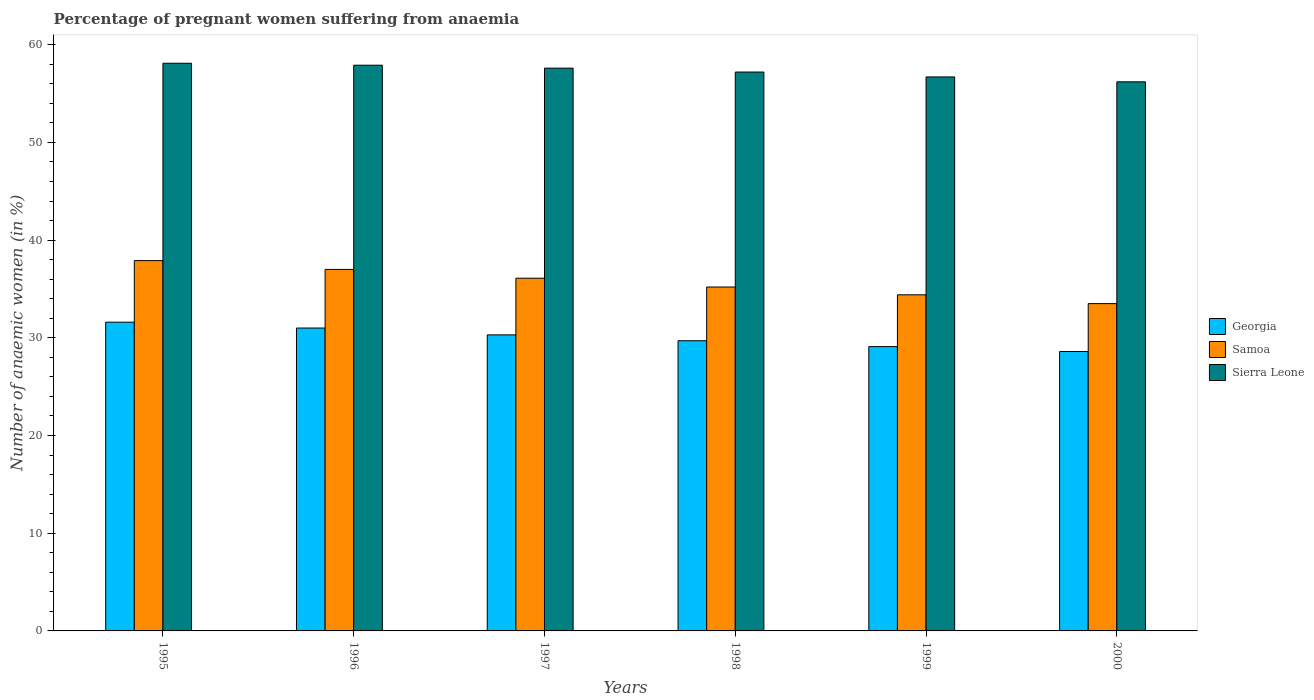How many different coloured bars are there?
Your response must be concise. 3. How many groups of bars are there?
Make the answer very short. 6. How many bars are there on the 2nd tick from the right?
Ensure brevity in your answer.  3. What is the number of anaemic women in Georgia in 1997?
Keep it short and to the point. 30.3. Across all years, what is the maximum number of anaemic women in Samoa?
Your response must be concise. 37.9. Across all years, what is the minimum number of anaemic women in Sierra Leone?
Your answer should be compact. 56.2. What is the total number of anaemic women in Sierra Leone in the graph?
Keep it short and to the point. 343.7. What is the difference between the number of anaemic women in Samoa in 1996 and that in 1999?
Ensure brevity in your answer.  2.6. What is the difference between the number of anaemic women in Sierra Leone in 2000 and the number of anaemic women in Georgia in 1997?
Your answer should be very brief. 25.9. What is the average number of anaemic women in Samoa per year?
Your answer should be compact. 35.68. In the year 1999, what is the difference between the number of anaemic women in Georgia and number of anaemic women in Samoa?
Your answer should be very brief. -5.3. In how many years, is the number of anaemic women in Georgia greater than 56 %?
Offer a terse response. 0. What is the ratio of the number of anaemic women in Samoa in 1995 to that in 1996?
Your answer should be very brief. 1.02. Is the number of anaemic women in Samoa in 1999 less than that in 2000?
Provide a succinct answer. No. What is the difference between the highest and the second highest number of anaemic women in Samoa?
Provide a short and direct response. 0.9. What is the difference between the highest and the lowest number of anaemic women in Samoa?
Offer a terse response. 4.4. In how many years, is the number of anaemic women in Samoa greater than the average number of anaemic women in Samoa taken over all years?
Provide a short and direct response. 3. What does the 2nd bar from the left in 1997 represents?
Ensure brevity in your answer.  Samoa. What does the 2nd bar from the right in 1999 represents?
Your response must be concise. Samoa. How many bars are there?
Your answer should be compact. 18. Are all the bars in the graph horizontal?
Make the answer very short. No. What is the difference between two consecutive major ticks on the Y-axis?
Keep it short and to the point. 10. Does the graph contain grids?
Your answer should be very brief. No. How many legend labels are there?
Ensure brevity in your answer.  3. How are the legend labels stacked?
Your answer should be very brief. Vertical. What is the title of the graph?
Your response must be concise. Percentage of pregnant women suffering from anaemia. What is the label or title of the Y-axis?
Your answer should be very brief. Number of anaemic women (in %). What is the Number of anaemic women (in %) in Georgia in 1995?
Your answer should be compact. 31.6. What is the Number of anaemic women (in %) in Samoa in 1995?
Your response must be concise. 37.9. What is the Number of anaemic women (in %) in Sierra Leone in 1995?
Keep it short and to the point. 58.1. What is the Number of anaemic women (in %) of Samoa in 1996?
Your answer should be very brief. 37. What is the Number of anaemic women (in %) in Sierra Leone in 1996?
Provide a short and direct response. 57.9. What is the Number of anaemic women (in %) of Georgia in 1997?
Ensure brevity in your answer.  30.3. What is the Number of anaemic women (in %) of Samoa in 1997?
Your answer should be very brief. 36.1. What is the Number of anaemic women (in %) in Sierra Leone in 1997?
Keep it short and to the point. 57.6. What is the Number of anaemic women (in %) of Georgia in 1998?
Offer a very short reply. 29.7. What is the Number of anaemic women (in %) in Samoa in 1998?
Ensure brevity in your answer.  35.2. What is the Number of anaemic women (in %) of Sierra Leone in 1998?
Give a very brief answer. 57.2. What is the Number of anaemic women (in %) in Georgia in 1999?
Ensure brevity in your answer.  29.1. What is the Number of anaemic women (in %) in Samoa in 1999?
Offer a terse response. 34.4. What is the Number of anaemic women (in %) of Sierra Leone in 1999?
Provide a succinct answer. 56.7. What is the Number of anaemic women (in %) in Georgia in 2000?
Give a very brief answer. 28.6. What is the Number of anaemic women (in %) of Samoa in 2000?
Your answer should be compact. 33.5. What is the Number of anaemic women (in %) of Sierra Leone in 2000?
Provide a short and direct response. 56.2. Across all years, what is the maximum Number of anaemic women (in %) of Georgia?
Keep it short and to the point. 31.6. Across all years, what is the maximum Number of anaemic women (in %) of Samoa?
Your response must be concise. 37.9. Across all years, what is the maximum Number of anaemic women (in %) of Sierra Leone?
Provide a short and direct response. 58.1. Across all years, what is the minimum Number of anaemic women (in %) in Georgia?
Provide a succinct answer. 28.6. Across all years, what is the minimum Number of anaemic women (in %) in Samoa?
Keep it short and to the point. 33.5. Across all years, what is the minimum Number of anaemic women (in %) of Sierra Leone?
Your answer should be very brief. 56.2. What is the total Number of anaemic women (in %) of Georgia in the graph?
Offer a terse response. 180.3. What is the total Number of anaemic women (in %) of Samoa in the graph?
Make the answer very short. 214.1. What is the total Number of anaemic women (in %) in Sierra Leone in the graph?
Your answer should be compact. 343.7. What is the difference between the Number of anaemic women (in %) in Samoa in 1995 and that in 1996?
Provide a succinct answer. 0.9. What is the difference between the Number of anaemic women (in %) of Samoa in 1995 and that in 1997?
Your response must be concise. 1.8. What is the difference between the Number of anaemic women (in %) of Georgia in 1995 and that in 1998?
Ensure brevity in your answer.  1.9. What is the difference between the Number of anaemic women (in %) in Samoa in 1995 and that in 1998?
Ensure brevity in your answer.  2.7. What is the difference between the Number of anaemic women (in %) of Samoa in 1995 and that in 1999?
Your answer should be very brief. 3.5. What is the difference between the Number of anaemic women (in %) in Sierra Leone in 1995 and that in 1999?
Offer a very short reply. 1.4. What is the difference between the Number of anaemic women (in %) of Georgia in 1995 and that in 2000?
Your answer should be very brief. 3. What is the difference between the Number of anaemic women (in %) in Samoa in 1995 and that in 2000?
Offer a terse response. 4.4. What is the difference between the Number of anaemic women (in %) of Sierra Leone in 1995 and that in 2000?
Make the answer very short. 1.9. What is the difference between the Number of anaemic women (in %) of Samoa in 1996 and that in 1997?
Offer a terse response. 0.9. What is the difference between the Number of anaemic women (in %) in Sierra Leone in 1996 and that in 1997?
Provide a succinct answer. 0.3. What is the difference between the Number of anaemic women (in %) of Georgia in 1996 and that in 1998?
Keep it short and to the point. 1.3. What is the difference between the Number of anaemic women (in %) in Sierra Leone in 1996 and that in 1998?
Your response must be concise. 0.7. What is the difference between the Number of anaemic women (in %) of Samoa in 1996 and that in 1999?
Provide a succinct answer. 2.6. What is the difference between the Number of anaemic women (in %) in Sierra Leone in 1996 and that in 1999?
Make the answer very short. 1.2. What is the difference between the Number of anaemic women (in %) in Samoa in 1996 and that in 2000?
Provide a succinct answer. 3.5. What is the difference between the Number of anaemic women (in %) in Sierra Leone in 1996 and that in 2000?
Your answer should be compact. 1.7. What is the difference between the Number of anaemic women (in %) in Georgia in 1997 and that in 1998?
Provide a short and direct response. 0.6. What is the difference between the Number of anaemic women (in %) of Samoa in 1997 and that in 1998?
Provide a succinct answer. 0.9. What is the difference between the Number of anaemic women (in %) in Samoa in 1997 and that in 1999?
Your response must be concise. 1.7. What is the difference between the Number of anaemic women (in %) in Sierra Leone in 1997 and that in 1999?
Provide a short and direct response. 0.9. What is the difference between the Number of anaemic women (in %) in Sierra Leone in 1997 and that in 2000?
Your response must be concise. 1.4. What is the difference between the Number of anaemic women (in %) in Georgia in 1998 and that in 1999?
Your answer should be very brief. 0.6. What is the difference between the Number of anaemic women (in %) of Sierra Leone in 1998 and that in 1999?
Your response must be concise. 0.5. What is the difference between the Number of anaemic women (in %) in Samoa in 1998 and that in 2000?
Ensure brevity in your answer.  1.7. What is the difference between the Number of anaemic women (in %) of Sierra Leone in 1998 and that in 2000?
Provide a succinct answer. 1. What is the difference between the Number of anaemic women (in %) in Samoa in 1999 and that in 2000?
Your answer should be very brief. 0.9. What is the difference between the Number of anaemic women (in %) in Georgia in 1995 and the Number of anaemic women (in %) in Sierra Leone in 1996?
Keep it short and to the point. -26.3. What is the difference between the Number of anaemic women (in %) of Georgia in 1995 and the Number of anaemic women (in %) of Samoa in 1997?
Give a very brief answer. -4.5. What is the difference between the Number of anaemic women (in %) of Samoa in 1995 and the Number of anaemic women (in %) of Sierra Leone in 1997?
Your answer should be compact. -19.7. What is the difference between the Number of anaemic women (in %) of Georgia in 1995 and the Number of anaemic women (in %) of Sierra Leone in 1998?
Offer a terse response. -25.6. What is the difference between the Number of anaemic women (in %) in Samoa in 1995 and the Number of anaemic women (in %) in Sierra Leone in 1998?
Ensure brevity in your answer.  -19.3. What is the difference between the Number of anaemic women (in %) in Georgia in 1995 and the Number of anaemic women (in %) in Samoa in 1999?
Your answer should be compact. -2.8. What is the difference between the Number of anaemic women (in %) of Georgia in 1995 and the Number of anaemic women (in %) of Sierra Leone in 1999?
Provide a short and direct response. -25.1. What is the difference between the Number of anaemic women (in %) of Samoa in 1995 and the Number of anaemic women (in %) of Sierra Leone in 1999?
Give a very brief answer. -18.8. What is the difference between the Number of anaemic women (in %) in Georgia in 1995 and the Number of anaemic women (in %) in Sierra Leone in 2000?
Keep it short and to the point. -24.6. What is the difference between the Number of anaemic women (in %) in Samoa in 1995 and the Number of anaemic women (in %) in Sierra Leone in 2000?
Your response must be concise. -18.3. What is the difference between the Number of anaemic women (in %) of Georgia in 1996 and the Number of anaemic women (in %) of Samoa in 1997?
Your response must be concise. -5.1. What is the difference between the Number of anaemic women (in %) of Georgia in 1996 and the Number of anaemic women (in %) of Sierra Leone in 1997?
Provide a short and direct response. -26.6. What is the difference between the Number of anaemic women (in %) in Samoa in 1996 and the Number of anaemic women (in %) in Sierra Leone in 1997?
Your response must be concise. -20.6. What is the difference between the Number of anaemic women (in %) of Georgia in 1996 and the Number of anaemic women (in %) of Samoa in 1998?
Ensure brevity in your answer.  -4.2. What is the difference between the Number of anaemic women (in %) of Georgia in 1996 and the Number of anaemic women (in %) of Sierra Leone in 1998?
Provide a short and direct response. -26.2. What is the difference between the Number of anaemic women (in %) in Samoa in 1996 and the Number of anaemic women (in %) in Sierra Leone in 1998?
Ensure brevity in your answer.  -20.2. What is the difference between the Number of anaemic women (in %) in Georgia in 1996 and the Number of anaemic women (in %) in Samoa in 1999?
Give a very brief answer. -3.4. What is the difference between the Number of anaemic women (in %) of Georgia in 1996 and the Number of anaemic women (in %) of Sierra Leone in 1999?
Keep it short and to the point. -25.7. What is the difference between the Number of anaemic women (in %) of Samoa in 1996 and the Number of anaemic women (in %) of Sierra Leone in 1999?
Provide a succinct answer. -19.7. What is the difference between the Number of anaemic women (in %) in Georgia in 1996 and the Number of anaemic women (in %) in Samoa in 2000?
Ensure brevity in your answer.  -2.5. What is the difference between the Number of anaemic women (in %) of Georgia in 1996 and the Number of anaemic women (in %) of Sierra Leone in 2000?
Ensure brevity in your answer.  -25.2. What is the difference between the Number of anaemic women (in %) of Samoa in 1996 and the Number of anaemic women (in %) of Sierra Leone in 2000?
Offer a very short reply. -19.2. What is the difference between the Number of anaemic women (in %) of Georgia in 1997 and the Number of anaemic women (in %) of Sierra Leone in 1998?
Ensure brevity in your answer.  -26.9. What is the difference between the Number of anaemic women (in %) of Samoa in 1997 and the Number of anaemic women (in %) of Sierra Leone in 1998?
Your answer should be very brief. -21.1. What is the difference between the Number of anaemic women (in %) in Georgia in 1997 and the Number of anaemic women (in %) in Sierra Leone in 1999?
Give a very brief answer. -26.4. What is the difference between the Number of anaemic women (in %) in Samoa in 1997 and the Number of anaemic women (in %) in Sierra Leone in 1999?
Make the answer very short. -20.6. What is the difference between the Number of anaemic women (in %) of Georgia in 1997 and the Number of anaemic women (in %) of Sierra Leone in 2000?
Your response must be concise. -25.9. What is the difference between the Number of anaemic women (in %) of Samoa in 1997 and the Number of anaemic women (in %) of Sierra Leone in 2000?
Offer a terse response. -20.1. What is the difference between the Number of anaemic women (in %) in Georgia in 1998 and the Number of anaemic women (in %) in Samoa in 1999?
Give a very brief answer. -4.7. What is the difference between the Number of anaemic women (in %) in Georgia in 1998 and the Number of anaemic women (in %) in Sierra Leone in 1999?
Provide a short and direct response. -27. What is the difference between the Number of anaemic women (in %) in Samoa in 1998 and the Number of anaemic women (in %) in Sierra Leone in 1999?
Offer a very short reply. -21.5. What is the difference between the Number of anaemic women (in %) in Georgia in 1998 and the Number of anaemic women (in %) in Samoa in 2000?
Ensure brevity in your answer.  -3.8. What is the difference between the Number of anaemic women (in %) in Georgia in 1998 and the Number of anaemic women (in %) in Sierra Leone in 2000?
Provide a short and direct response. -26.5. What is the difference between the Number of anaemic women (in %) of Georgia in 1999 and the Number of anaemic women (in %) of Samoa in 2000?
Your answer should be very brief. -4.4. What is the difference between the Number of anaemic women (in %) in Georgia in 1999 and the Number of anaemic women (in %) in Sierra Leone in 2000?
Provide a succinct answer. -27.1. What is the difference between the Number of anaemic women (in %) in Samoa in 1999 and the Number of anaemic women (in %) in Sierra Leone in 2000?
Provide a short and direct response. -21.8. What is the average Number of anaemic women (in %) in Georgia per year?
Provide a short and direct response. 30.05. What is the average Number of anaemic women (in %) of Samoa per year?
Ensure brevity in your answer.  35.68. What is the average Number of anaemic women (in %) in Sierra Leone per year?
Offer a terse response. 57.28. In the year 1995, what is the difference between the Number of anaemic women (in %) in Georgia and Number of anaemic women (in %) in Sierra Leone?
Give a very brief answer. -26.5. In the year 1995, what is the difference between the Number of anaemic women (in %) in Samoa and Number of anaemic women (in %) in Sierra Leone?
Provide a succinct answer. -20.2. In the year 1996, what is the difference between the Number of anaemic women (in %) of Georgia and Number of anaemic women (in %) of Samoa?
Keep it short and to the point. -6. In the year 1996, what is the difference between the Number of anaemic women (in %) of Georgia and Number of anaemic women (in %) of Sierra Leone?
Your answer should be compact. -26.9. In the year 1996, what is the difference between the Number of anaemic women (in %) of Samoa and Number of anaemic women (in %) of Sierra Leone?
Provide a short and direct response. -20.9. In the year 1997, what is the difference between the Number of anaemic women (in %) in Georgia and Number of anaemic women (in %) in Sierra Leone?
Your answer should be compact. -27.3. In the year 1997, what is the difference between the Number of anaemic women (in %) of Samoa and Number of anaemic women (in %) of Sierra Leone?
Provide a short and direct response. -21.5. In the year 1998, what is the difference between the Number of anaemic women (in %) in Georgia and Number of anaemic women (in %) in Samoa?
Your answer should be compact. -5.5. In the year 1998, what is the difference between the Number of anaemic women (in %) of Georgia and Number of anaemic women (in %) of Sierra Leone?
Your answer should be compact. -27.5. In the year 1998, what is the difference between the Number of anaemic women (in %) in Samoa and Number of anaemic women (in %) in Sierra Leone?
Provide a short and direct response. -22. In the year 1999, what is the difference between the Number of anaemic women (in %) of Georgia and Number of anaemic women (in %) of Samoa?
Your answer should be very brief. -5.3. In the year 1999, what is the difference between the Number of anaemic women (in %) of Georgia and Number of anaemic women (in %) of Sierra Leone?
Give a very brief answer. -27.6. In the year 1999, what is the difference between the Number of anaemic women (in %) in Samoa and Number of anaemic women (in %) in Sierra Leone?
Your answer should be compact. -22.3. In the year 2000, what is the difference between the Number of anaemic women (in %) of Georgia and Number of anaemic women (in %) of Samoa?
Your answer should be very brief. -4.9. In the year 2000, what is the difference between the Number of anaemic women (in %) of Georgia and Number of anaemic women (in %) of Sierra Leone?
Your response must be concise. -27.6. In the year 2000, what is the difference between the Number of anaemic women (in %) in Samoa and Number of anaemic women (in %) in Sierra Leone?
Your response must be concise. -22.7. What is the ratio of the Number of anaemic women (in %) in Georgia in 1995 to that in 1996?
Ensure brevity in your answer.  1.02. What is the ratio of the Number of anaemic women (in %) of Samoa in 1995 to that in 1996?
Provide a succinct answer. 1.02. What is the ratio of the Number of anaemic women (in %) in Sierra Leone in 1995 to that in 1996?
Offer a very short reply. 1. What is the ratio of the Number of anaemic women (in %) in Georgia in 1995 to that in 1997?
Offer a very short reply. 1.04. What is the ratio of the Number of anaemic women (in %) of Samoa in 1995 to that in 1997?
Give a very brief answer. 1.05. What is the ratio of the Number of anaemic women (in %) of Sierra Leone in 1995 to that in 1997?
Provide a short and direct response. 1.01. What is the ratio of the Number of anaemic women (in %) of Georgia in 1995 to that in 1998?
Your answer should be very brief. 1.06. What is the ratio of the Number of anaemic women (in %) in Samoa in 1995 to that in 1998?
Make the answer very short. 1.08. What is the ratio of the Number of anaemic women (in %) of Sierra Leone in 1995 to that in 1998?
Provide a succinct answer. 1.02. What is the ratio of the Number of anaemic women (in %) of Georgia in 1995 to that in 1999?
Your response must be concise. 1.09. What is the ratio of the Number of anaemic women (in %) of Samoa in 1995 to that in 1999?
Keep it short and to the point. 1.1. What is the ratio of the Number of anaemic women (in %) of Sierra Leone in 1995 to that in 1999?
Your answer should be very brief. 1.02. What is the ratio of the Number of anaemic women (in %) in Georgia in 1995 to that in 2000?
Keep it short and to the point. 1.1. What is the ratio of the Number of anaemic women (in %) of Samoa in 1995 to that in 2000?
Ensure brevity in your answer.  1.13. What is the ratio of the Number of anaemic women (in %) of Sierra Leone in 1995 to that in 2000?
Provide a succinct answer. 1.03. What is the ratio of the Number of anaemic women (in %) in Georgia in 1996 to that in 1997?
Offer a very short reply. 1.02. What is the ratio of the Number of anaemic women (in %) in Samoa in 1996 to that in 1997?
Provide a succinct answer. 1.02. What is the ratio of the Number of anaemic women (in %) in Georgia in 1996 to that in 1998?
Keep it short and to the point. 1.04. What is the ratio of the Number of anaemic women (in %) of Samoa in 1996 to that in 1998?
Provide a short and direct response. 1.05. What is the ratio of the Number of anaemic women (in %) in Sierra Leone in 1996 to that in 1998?
Your answer should be very brief. 1.01. What is the ratio of the Number of anaemic women (in %) of Georgia in 1996 to that in 1999?
Make the answer very short. 1.07. What is the ratio of the Number of anaemic women (in %) in Samoa in 1996 to that in 1999?
Offer a terse response. 1.08. What is the ratio of the Number of anaemic women (in %) in Sierra Leone in 1996 to that in 1999?
Ensure brevity in your answer.  1.02. What is the ratio of the Number of anaemic women (in %) in Georgia in 1996 to that in 2000?
Your response must be concise. 1.08. What is the ratio of the Number of anaemic women (in %) of Samoa in 1996 to that in 2000?
Your answer should be compact. 1.1. What is the ratio of the Number of anaemic women (in %) of Sierra Leone in 1996 to that in 2000?
Provide a succinct answer. 1.03. What is the ratio of the Number of anaemic women (in %) in Georgia in 1997 to that in 1998?
Your answer should be very brief. 1.02. What is the ratio of the Number of anaemic women (in %) of Samoa in 1997 to that in 1998?
Ensure brevity in your answer.  1.03. What is the ratio of the Number of anaemic women (in %) of Georgia in 1997 to that in 1999?
Your answer should be very brief. 1.04. What is the ratio of the Number of anaemic women (in %) in Samoa in 1997 to that in 1999?
Your answer should be compact. 1.05. What is the ratio of the Number of anaemic women (in %) of Sierra Leone in 1997 to that in 1999?
Provide a short and direct response. 1.02. What is the ratio of the Number of anaemic women (in %) of Georgia in 1997 to that in 2000?
Provide a short and direct response. 1.06. What is the ratio of the Number of anaemic women (in %) of Samoa in 1997 to that in 2000?
Provide a succinct answer. 1.08. What is the ratio of the Number of anaemic women (in %) in Sierra Leone in 1997 to that in 2000?
Make the answer very short. 1.02. What is the ratio of the Number of anaemic women (in %) in Georgia in 1998 to that in 1999?
Offer a very short reply. 1.02. What is the ratio of the Number of anaemic women (in %) of Samoa in 1998 to that in 1999?
Keep it short and to the point. 1.02. What is the ratio of the Number of anaemic women (in %) of Sierra Leone in 1998 to that in 1999?
Offer a terse response. 1.01. What is the ratio of the Number of anaemic women (in %) of Samoa in 1998 to that in 2000?
Your response must be concise. 1.05. What is the ratio of the Number of anaemic women (in %) in Sierra Leone in 1998 to that in 2000?
Ensure brevity in your answer.  1.02. What is the ratio of the Number of anaemic women (in %) of Georgia in 1999 to that in 2000?
Keep it short and to the point. 1.02. What is the ratio of the Number of anaemic women (in %) in Samoa in 1999 to that in 2000?
Provide a short and direct response. 1.03. What is the ratio of the Number of anaemic women (in %) of Sierra Leone in 1999 to that in 2000?
Your answer should be compact. 1.01. What is the difference between the highest and the second highest Number of anaemic women (in %) of Georgia?
Your answer should be very brief. 0.6. What is the difference between the highest and the second highest Number of anaemic women (in %) in Samoa?
Ensure brevity in your answer.  0.9. What is the difference between the highest and the lowest Number of anaemic women (in %) of Georgia?
Provide a succinct answer. 3. What is the difference between the highest and the lowest Number of anaemic women (in %) of Samoa?
Ensure brevity in your answer.  4.4. 